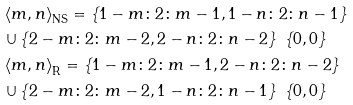Convert formula to latex. <formula><loc_0><loc_0><loc_500><loc_500>& \left \langle m , n \right \rangle _ { \text {NS} } = \left \{ 1 - m \colon 2 \colon m - 1 , 1 - n \colon 2 \colon n - 1 \right \} \\ & \cup \left \{ 2 - m \colon 2 \colon m - 2 , 2 - n \colon 2 \colon n - 2 \right \} \ \{ 0 , 0 \} \\ & \left \langle m , n \right \rangle _ { \text {R} } = \left \{ 1 - m \colon 2 \colon m - 1 , 2 - n \colon 2 \colon n - 2 \right \} \\ & \cup \left \{ 2 - m \colon 2 \colon m - 2 , 1 - n \colon 2 \colon n - 1 \right \} \ \{ 0 , 0 \}</formula> 